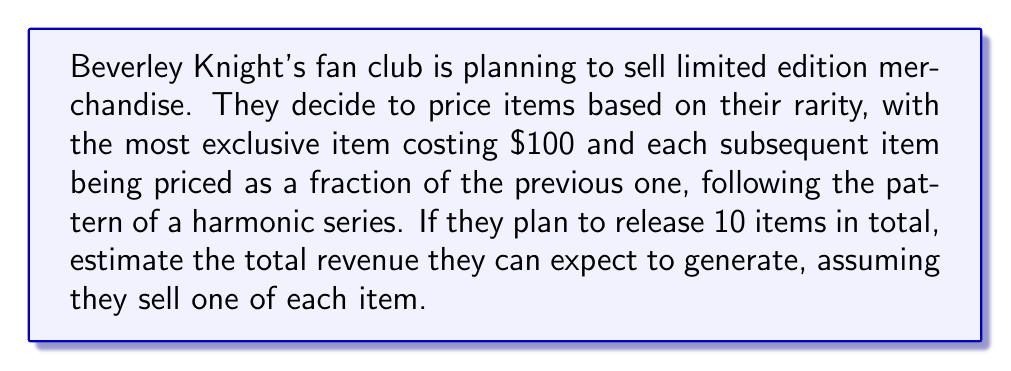Show me your answer to this math problem. Let's approach this step-by-step:

1) The prices of the items form a harmonic series:
   $$100, 100/2, 100/3, 100/4, ..., 100/10$$

2) The total revenue will be the sum of this series:
   $$S = 100(1 + \frac{1}{2} + \frac{1}{3} + \frac{1}{4} + ... + \frac{1}{10})$$

3) This is a partial sum of the harmonic series. We can estimate it using the integral of 1/x:
   $$\int_{1}^{10} \frac{1}{x} dx = \ln(10) - \ln(1) = \ln(10) \approx 2.30$$

4) However, the harmonic series always slightly exceeds this integral. A better approximation is:
   $$\sum_{k=1}^{n} \frac{1}{k} \approx \ln(n) + \gamma$$
   where $\gamma$ is the Euler-Mascheroni constant, approximately 0.5772.

5) So, our estimate becomes:
   $$S \approx 100(\ln(10) + 0.5772) \approx 100(2.30 + 0.5772) = 100(2.8772)$$

6) Calculate the final result:
   $$S \approx 100 * 2.8772 = 287.72$$

Therefore, the estimated total revenue is approximately $287.72.
Answer: $287.72 